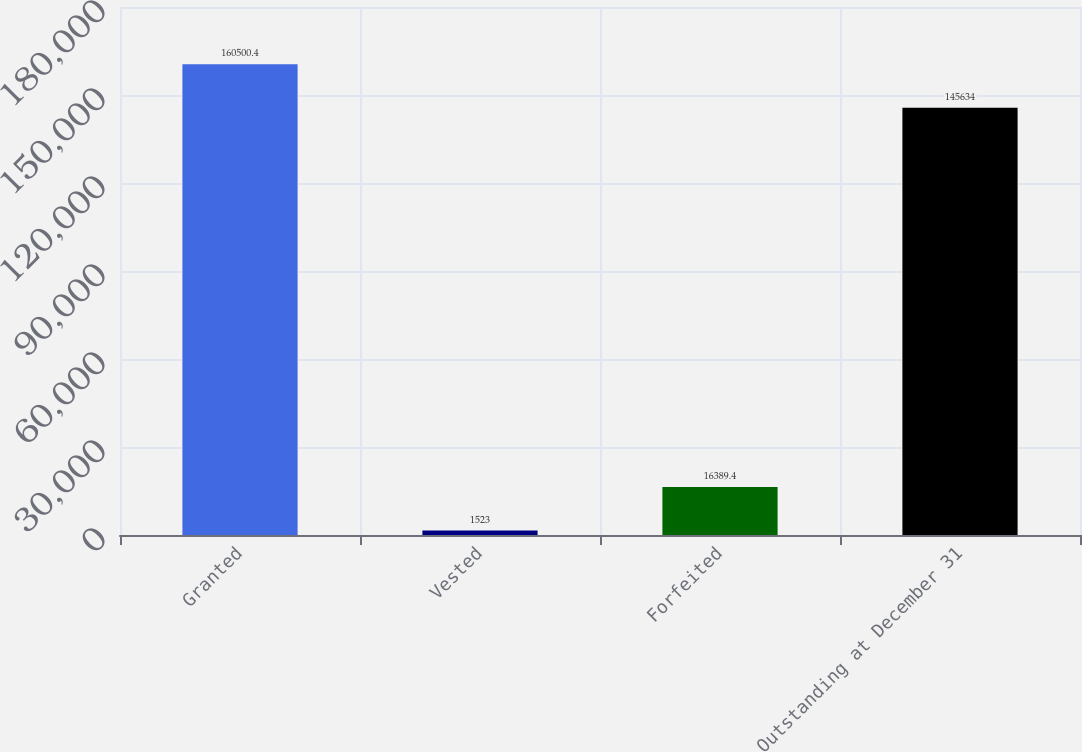Convert chart to OTSL. <chart><loc_0><loc_0><loc_500><loc_500><bar_chart><fcel>Granted<fcel>Vested<fcel>Forfeited<fcel>Outstanding at December 31<nl><fcel>160500<fcel>1523<fcel>16389.4<fcel>145634<nl></chart> 